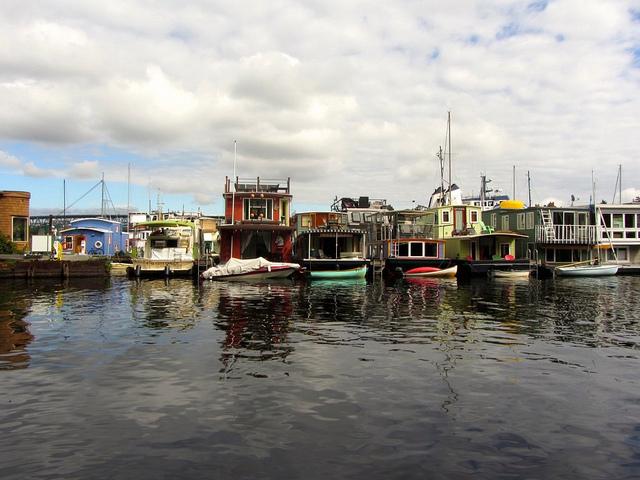Are there reflections?
Concise answer only. Yes. What do all of the boats have on them to protect them?
Short answer required. Covers. Is the sky cloudy?
Keep it brief. Yes. Is the weather good for boating?
Keep it brief. Yes. How many boats are there in this picture?
Short answer required. 8. How many boats are in the photo?
Be succinct. 12. 